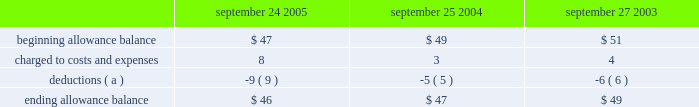Notes to consolidated financial statements ( continued ) note 2 2014financial instruments ( continued ) are not covered by collateral , third-party flooring arrangements , or credit insurance are outstanding with the company 2019s distribution and retail channel partners .
No customer accounted for more than 10% ( 10 % ) of trade receivables as of september 24 , 2005 or september 25 , 2004 .
The table summarizes the activity in the allowance for doubtful accounts ( in millions ) : september 24 , september 25 , september 27 .
( a ) represents amounts written off against the allowance , net of recoveries .
Vendor non-trade receivables the company has non-trade receivables from certain of its manufacturing vendors resulting from the sale of raw material components to these manufacturing vendors who manufacture sub-assemblies or assemble final products for the company .
The company purchases these raw material components directly from suppliers .
These non-trade receivables , which are included in the consolidated balance sheets in other current assets , totaled $ 417 million and $ 276 million as of september 24 , 2005 and september 25 , 2004 , respectively .
The company does not reflect the sale of these components in net sales and does not recognize any profits on these sales until the products are sold through to the end customer at which time the profit is recognized as a reduction of cost of sales .
Derivative financial instruments the company uses derivatives to partially offset its business exposure to foreign exchange and interest rate risk .
Foreign currency forward and option contracts are used to offset the foreign exchange risk on certain existing assets and liabilities and to hedge the foreign exchange risk on expected future cash flows on certain forecasted revenue and cost of sales .
From time to time , the company enters into interest rate derivative agreements to modify the interest rate profile of certain investments and debt .
The company 2019s accounting policies for these instruments are based on whether the instruments are designated as hedge or non-hedge instruments .
The company records all derivatives on the balance sheet at fair value. .
What was the change in non-trade receivables , which are included in the consolidated balance sheets in other current assets , between september 24 , 2005 and september 25 , 2004 , in millions? 
Computations: (417 - 276)
Answer: 141.0. 